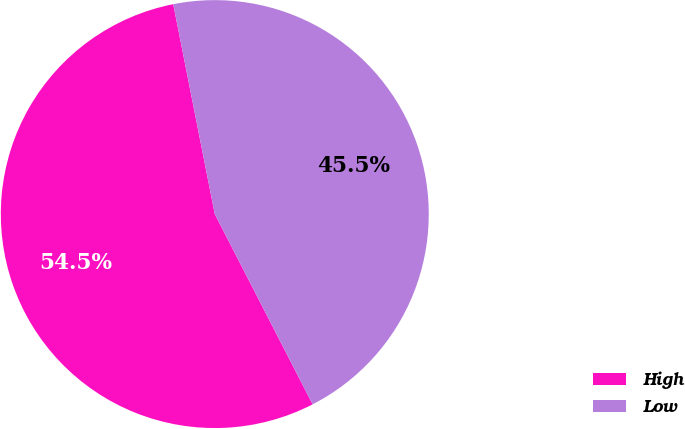Convert chart. <chart><loc_0><loc_0><loc_500><loc_500><pie_chart><fcel>High<fcel>Low<nl><fcel>54.45%<fcel>45.55%<nl></chart> 